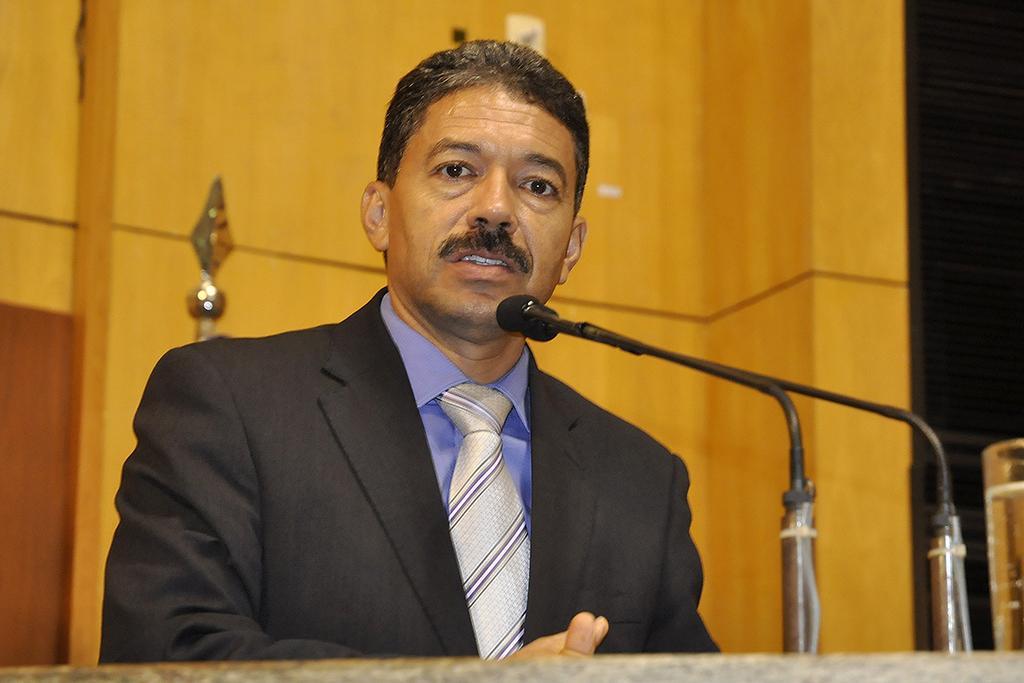In one or two sentences, can you explain what this image depicts? A man is standing wearing a suit. There is a microphone at the front. There is a glass of water at the right. There is a wooden background. 